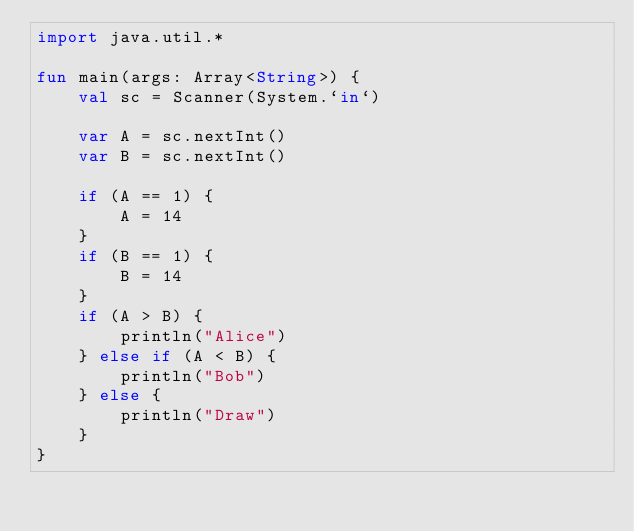Convert code to text. <code><loc_0><loc_0><loc_500><loc_500><_Kotlin_>import java.util.*

fun main(args: Array<String>) {
    val sc = Scanner(System.`in`)

    var A = sc.nextInt()
    var B = sc.nextInt()

    if (A == 1) {
        A = 14
    }
    if (B == 1) {
        B = 14
    }
    if (A > B) {
        println("Alice")
    } else if (A < B) {
        println("Bob")
    } else {
        println("Draw")
    }
}
</code> 